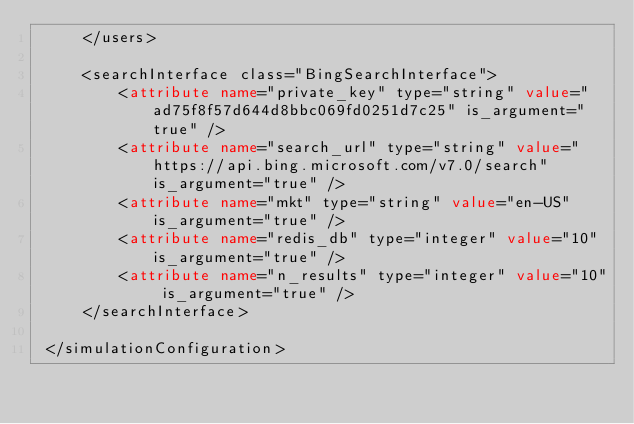<code> <loc_0><loc_0><loc_500><loc_500><_XML_>     </users>

     <searchInterface class="BingSearchInterface">
         <attribute name="private_key" type="string" value="ad75f8f57d644d8bbc069fd0251d7c25" is_argument="true" />
         <attribute name="search_url" type="string" value="https://api.bing.microsoft.com/v7.0/search" is_argument="true" />
         <attribute name="mkt" type="string" value="en-US" is_argument="true" />
         <attribute name="redis_db" type="integer" value="10" is_argument="true" />
         <attribute name="n_results" type="integer" value="10" is_argument="true" />
     </searchInterface>

 </simulationConfiguration></code> 